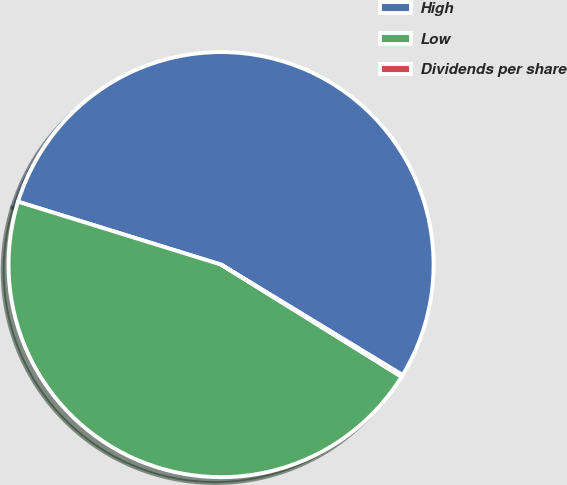Convert chart. <chart><loc_0><loc_0><loc_500><loc_500><pie_chart><fcel>High<fcel>Low<fcel>Dividends per share<nl><fcel>53.92%<fcel>45.93%<fcel>0.15%<nl></chart> 